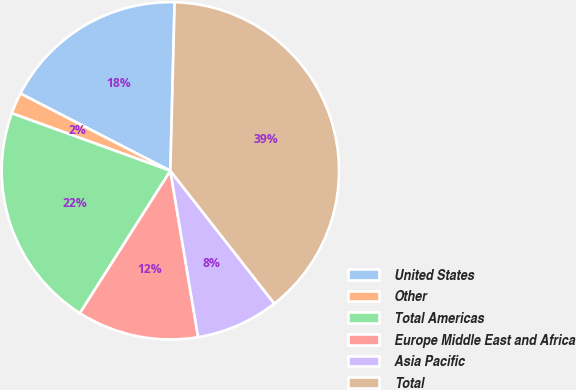Convert chart. <chart><loc_0><loc_0><loc_500><loc_500><pie_chart><fcel>United States<fcel>Other<fcel>Total Americas<fcel>Europe Middle East and Africa<fcel>Asia Pacific<fcel>Total<nl><fcel>17.83%<fcel>2.03%<fcel>21.53%<fcel>11.64%<fcel>7.94%<fcel>39.02%<nl></chart> 